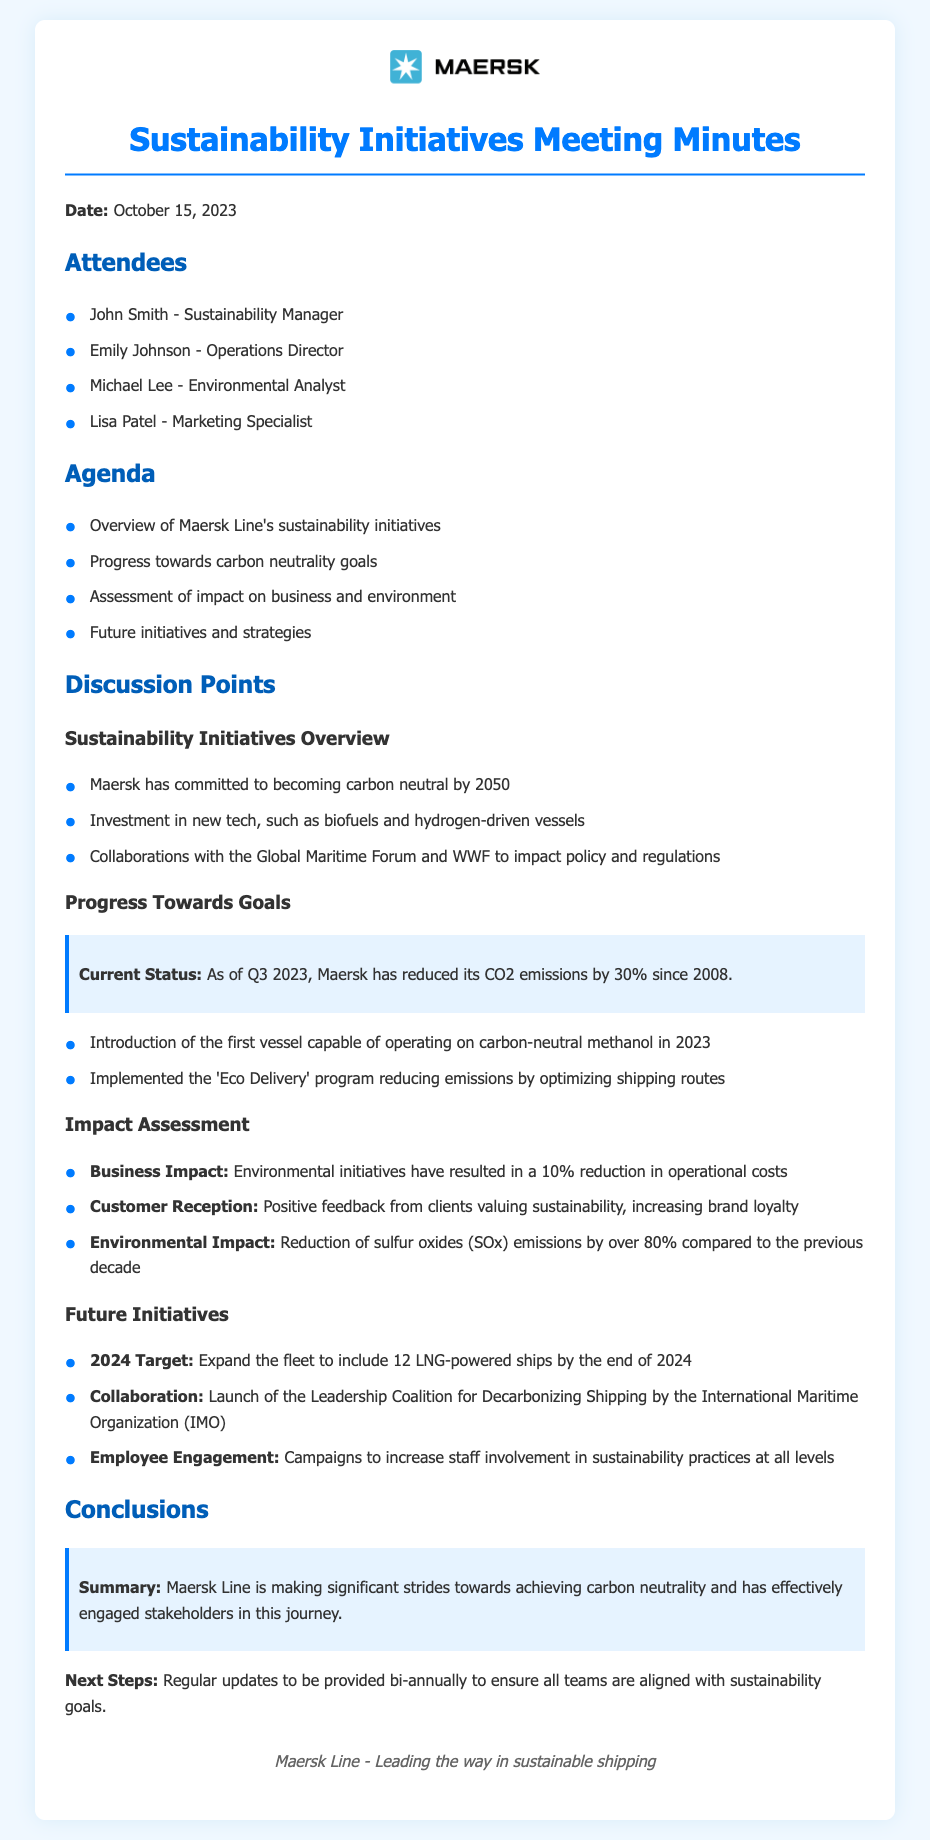what is the date of the meeting? The date listed in the document for the meeting is October 15, 2023.
Answer: October 15, 2023 who is the Sustainability Manager? The name of the Sustainability Manager mentioned in the document is John Smith.
Answer: John Smith what percentage has Maersk Line reduced its CO2 emissions since 2008? The document states that Maersk has reduced its CO2 emissions by 30% since 2008.
Answer: 30% what is the 2024 target for Maersk Line's fleet? The document indicates that the target for 2024 is to expand the fleet to include 12 LNG-powered ships by the end of 2024.
Answer: 12 LNG-powered ships how much have operational costs been reduced due to environmental initiatives? According to the document, environmental initiatives have resulted in a 10% reduction in operational costs.
Answer: 10% which program has reduced emissions by optimizing shipping routes? The program mentioned in the document that reduces emissions by optimizing shipping routes is called 'Eco Delivery'.
Answer: Eco Delivery what organization is launching the Leadership Coalition for Decarbonizing Shipping? The organization stated in the document that is launching the Leadership Coalition is the International Maritime Organization (IMO).
Answer: International Maritime Organization (IMO) what has been the reduction of sulfur oxides emissions compared to the previous decade? The document notes that there has been a reduction of sulfur oxides (SOx) emissions by over 80% compared to the previous decade.
Answer: over 80% 